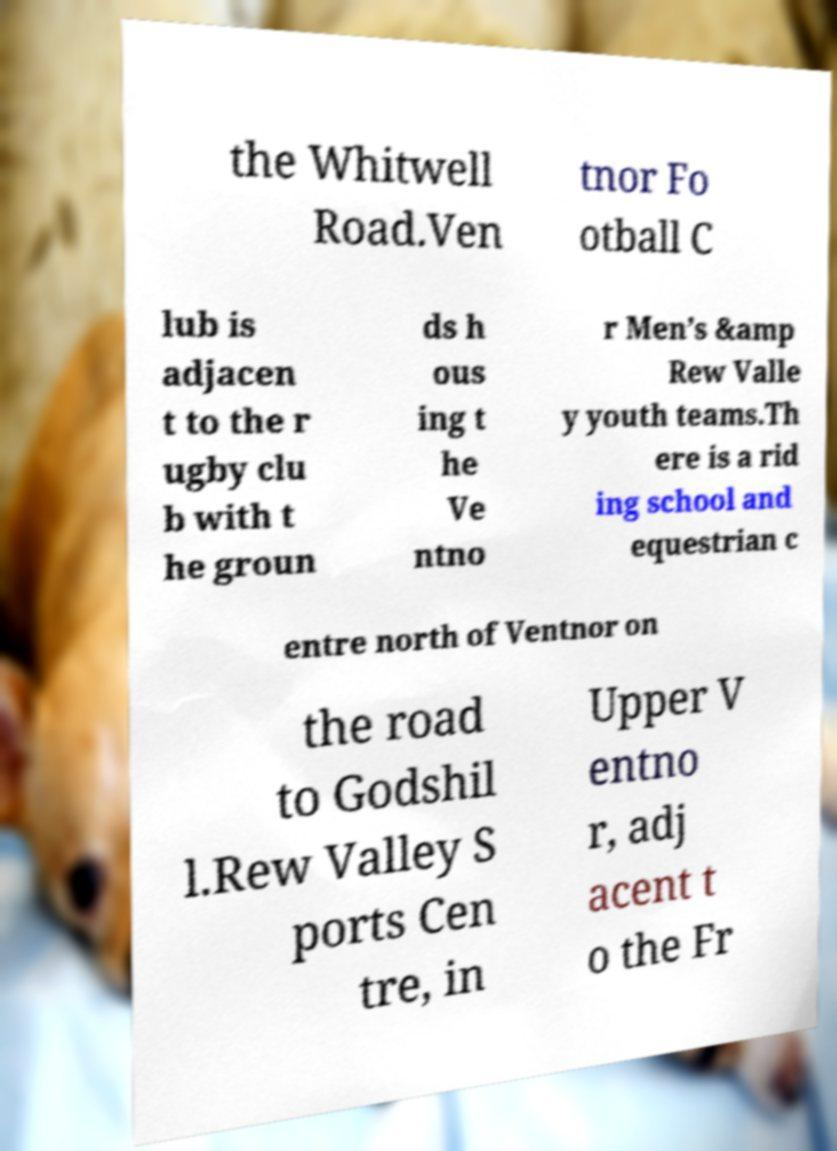There's text embedded in this image that I need extracted. Can you transcribe it verbatim? the Whitwell Road.Ven tnor Fo otball C lub is adjacen t to the r ugby clu b with t he groun ds h ous ing t he Ve ntno r Men’s &amp Rew Valle y youth teams.Th ere is a rid ing school and equestrian c entre north of Ventnor on the road to Godshil l.Rew Valley S ports Cen tre, in Upper V entno r, adj acent t o the Fr 